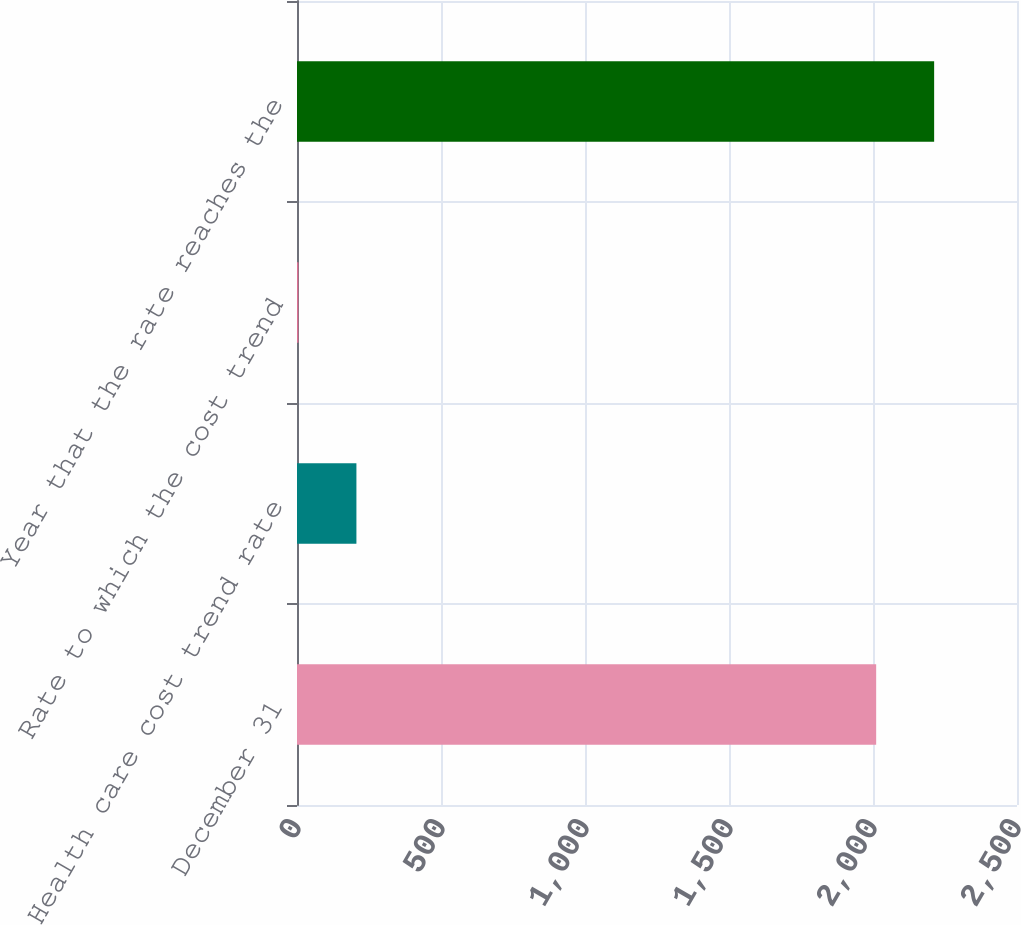Convert chart to OTSL. <chart><loc_0><loc_0><loc_500><loc_500><bar_chart><fcel>December 31<fcel>Health care cost trend rate<fcel>Rate to which the cost trend<fcel>Year that the rate reaches the<nl><fcel>2011<fcel>206.3<fcel>5<fcel>2212.3<nl></chart> 